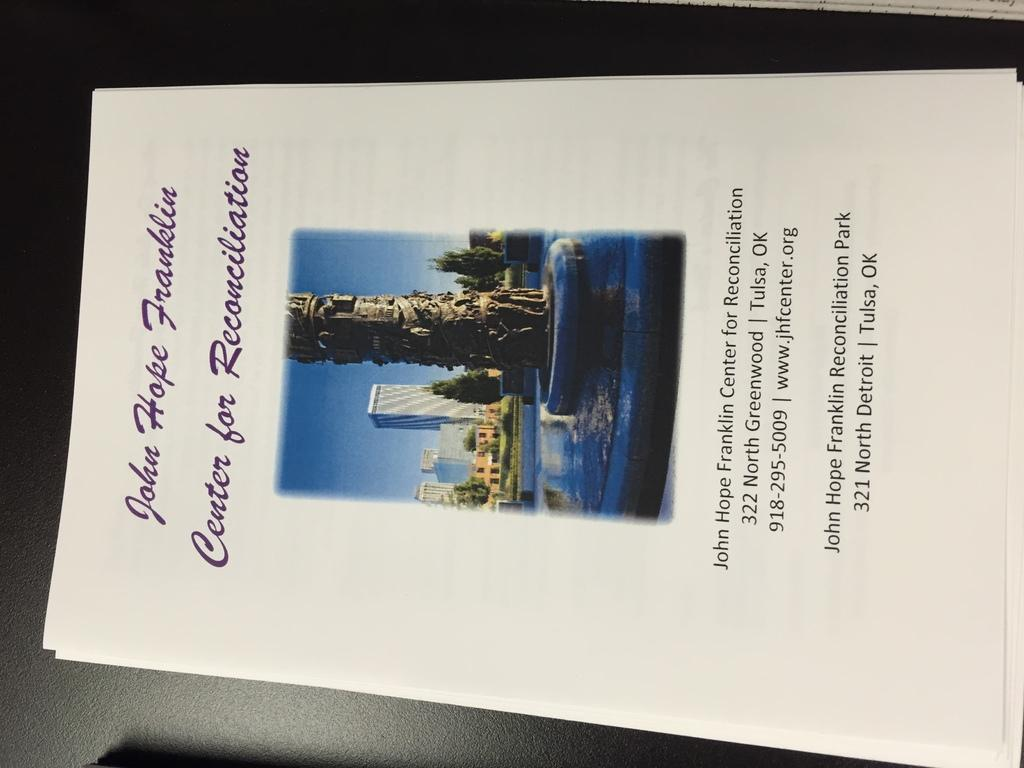<image>
Present a compact description of the photo's key features. Some flyers for the John Hope Franklin Center for Reconciliation. 